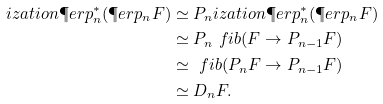Convert formula to latex. <formula><loc_0><loc_0><loc_500><loc_500>\real i z a t i o n { \P e r p _ { n } ^ { * } ( \P e r p _ { n } F ) } & \simeq P _ { n } \real i z a t i o n { \P e r p _ { n } ^ { * } ( \P e r p _ { n } F ) } \\ & \simeq P _ { n } \ f i b ( F \rightarrow P _ { n - 1 } F ) \\ & \simeq \ f i b ( P _ { n } F \rightarrow P _ { n - 1 } F ) \\ & \simeq D _ { n } F .</formula> 